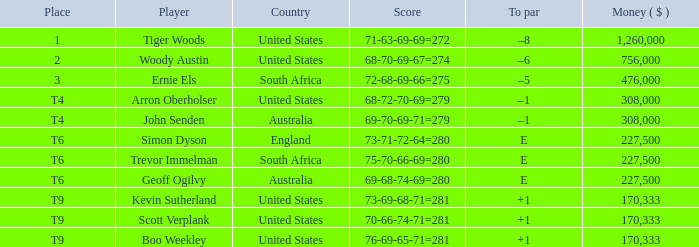In what spot did the english player end up? T6. 